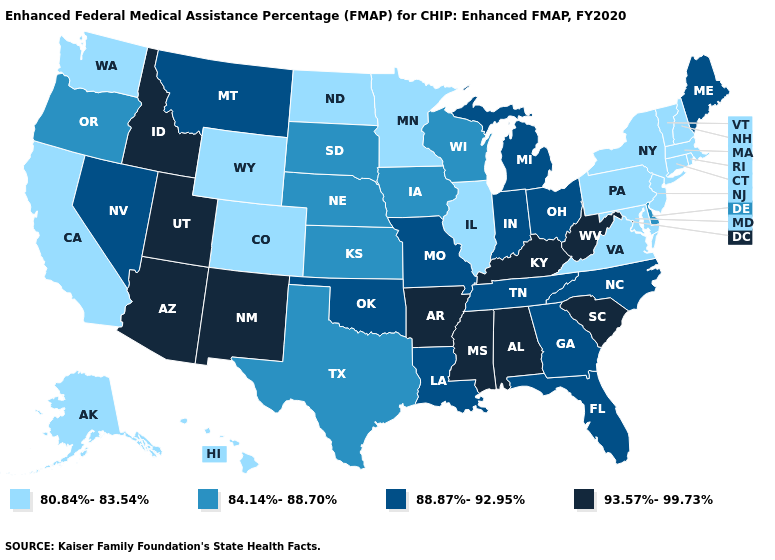Name the states that have a value in the range 93.57%-99.73%?
Give a very brief answer. Alabama, Arizona, Arkansas, Idaho, Kentucky, Mississippi, New Mexico, South Carolina, Utah, West Virginia. Is the legend a continuous bar?
Short answer required. No. Name the states that have a value in the range 93.57%-99.73%?
Give a very brief answer. Alabama, Arizona, Arkansas, Idaho, Kentucky, Mississippi, New Mexico, South Carolina, Utah, West Virginia. Name the states that have a value in the range 88.87%-92.95%?
Answer briefly. Florida, Georgia, Indiana, Louisiana, Maine, Michigan, Missouri, Montana, Nevada, North Carolina, Ohio, Oklahoma, Tennessee. Name the states that have a value in the range 80.84%-83.54%?
Short answer required. Alaska, California, Colorado, Connecticut, Hawaii, Illinois, Maryland, Massachusetts, Minnesota, New Hampshire, New Jersey, New York, North Dakota, Pennsylvania, Rhode Island, Vermont, Virginia, Washington, Wyoming. Name the states that have a value in the range 80.84%-83.54%?
Keep it brief. Alaska, California, Colorado, Connecticut, Hawaii, Illinois, Maryland, Massachusetts, Minnesota, New Hampshire, New Jersey, New York, North Dakota, Pennsylvania, Rhode Island, Vermont, Virginia, Washington, Wyoming. Does the map have missing data?
Answer briefly. No. Among the states that border Michigan , does Indiana have the highest value?
Give a very brief answer. Yes. Name the states that have a value in the range 84.14%-88.70%?
Quick response, please. Delaware, Iowa, Kansas, Nebraska, Oregon, South Dakota, Texas, Wisconsin. What is the highest value in the USA?
Keep it brief. 93.57%-99.73%. Name the states that have a value in the range 93.57%-99.73%?
Quick response, please. Alabama, Arizona, Arkansas, Idaho, Kentucky, Mississippi, New Mexico, South Carolina, Utah, West Virginia. Is the legend a continuous bar?
Be succinct. No. Does the map have missing data?
Write a very short answer. No. How many symbols are there in the legend?
Give a very brief answer. 4. Which states hav the highest value in the South?
Write a very short answer. Alabama, Arkansas, Kentucky, Mississippi, South Carolina, West Virginia. 